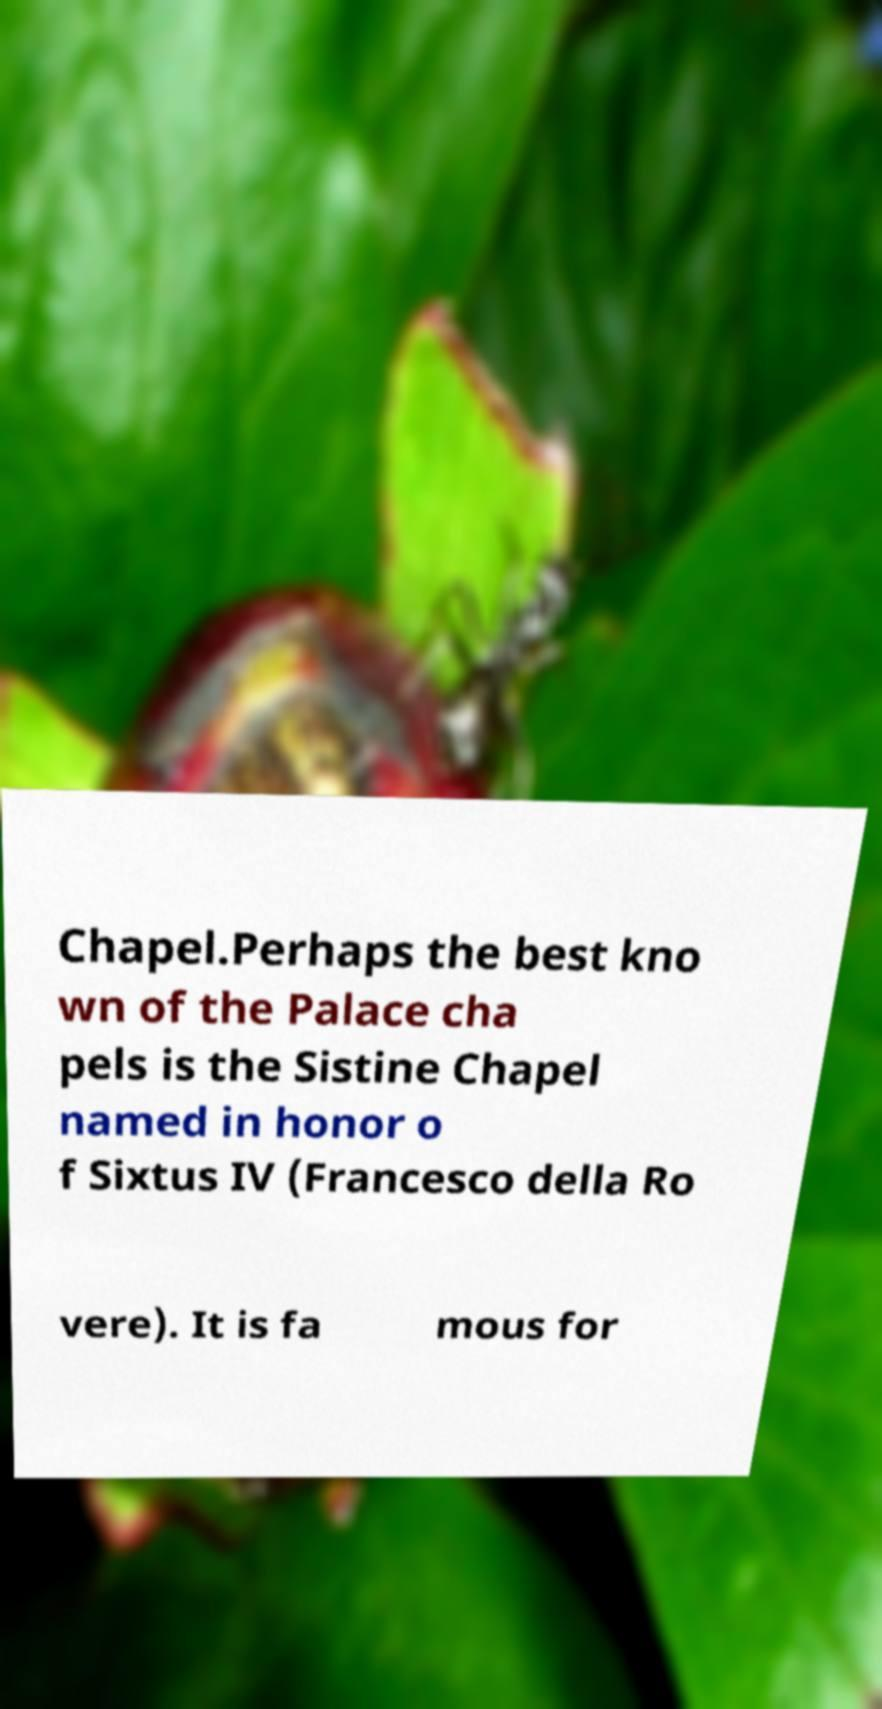Please identify and transcribe the text found in this image. Chapel.Perhaps the best kno wn of the Palace cha pels is the Sistine Chapel named in honor o f Sixtus IV (Francesco della Ro vere). It is fa mous for 